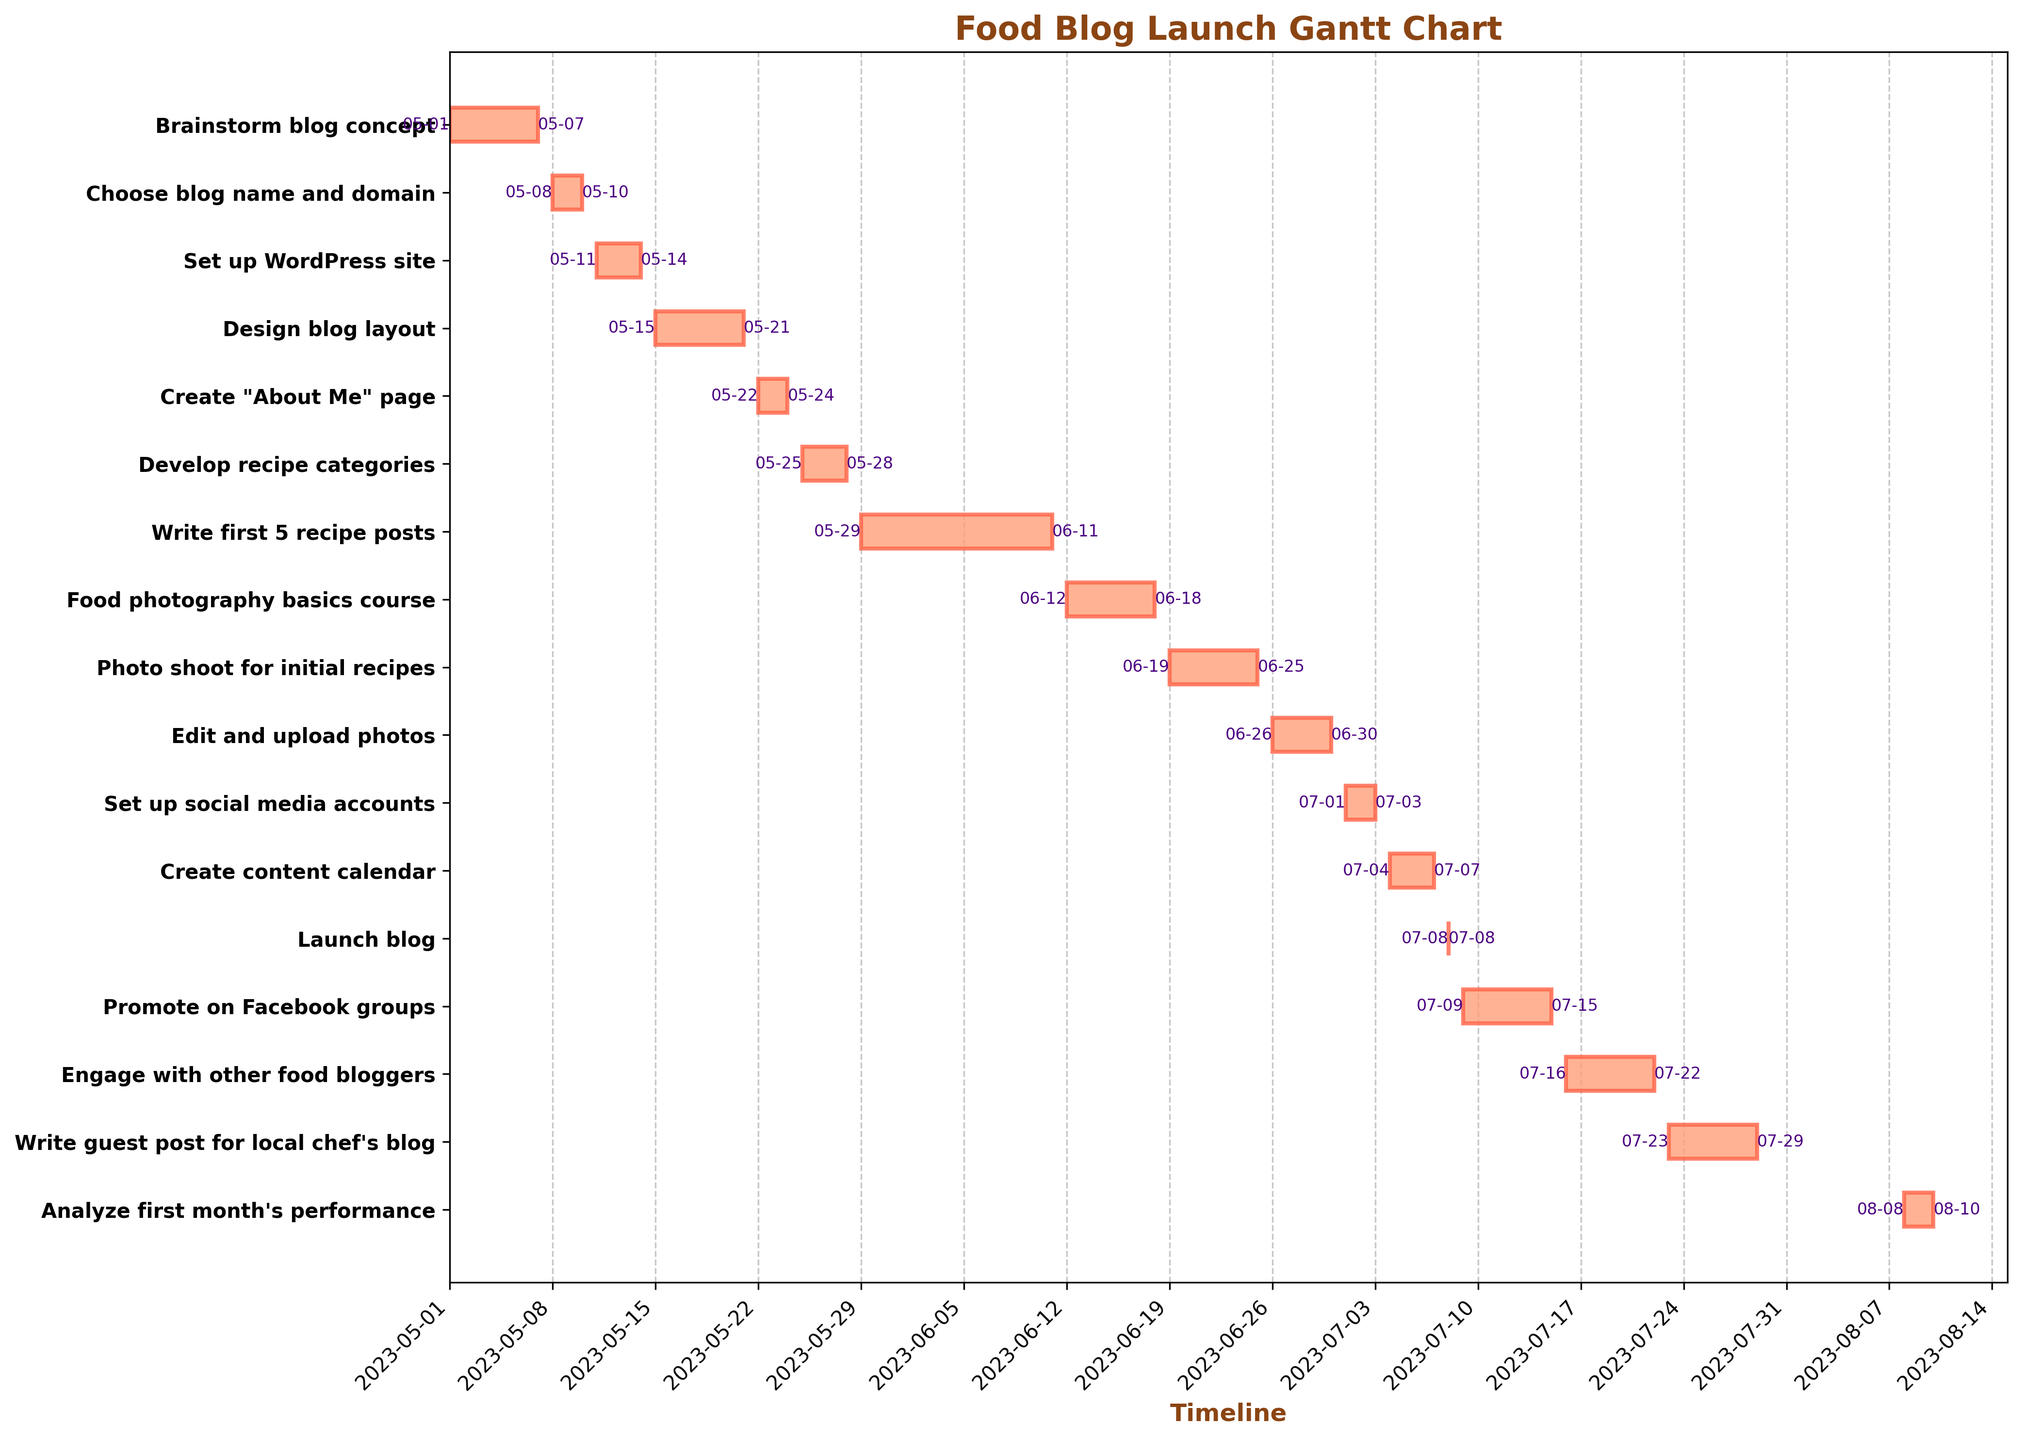What is the title of the Gantt chart? The title is located at the top of the chart and is presented in bold text. Reading the title tells us the main subject or focus of the chart.
Answer: Food Blog Launch Gantt Chart How long did the task 'Brainstorm blog concept' take? To determine the duration, look at the start and end dates (May 1, 2023, to May 7, 2023) and calculate the difference in days.
Answer: 7 days Which task overlaps with setting up the WordPress site? 'Setting up the WordPress site' runs from May 11, 2023, to May 14, 2023. Check for other tasks occurring within or across these dates. 'Choose blog name and domain' ends on May 10 and 'Design blog layout' starts on May 15, so there is no overlap.
Answer: None Which task took the longest time to complete? Examine the lengths of all horizontal bars representing each task. The longest bar corresponds to the task 'Write first 5 recipe posts' with a duration from May 29, 2023, to June 11, 2023.
Answer: Write first 5 recipe posts How many tasks are there in total? Each horizontal bar represents one task. Counting all the bars gives the total number of tasks. There are 17 bars on the chart.
Answer: 17 tasks In which week is the blog officially launched? The launch date, July 8, 2023, falls within a specific week. Identify this week on the timeline axis.
Answer: Week of July 3, 2023 What's the difference in days between the start of the 'Food photography basics course' and the 'Launch blog'? The 'Food photography basics course' starts on June 12, 2023, and 'Launch blog' on July 8, 2023. Calculate the difference in days between these two dates.
Answer: 26 days How many stages/tasks are involved from brainstorming the blog concept to creating the 'About Me' page? Identify and count the bars from 'Brainstorm blog concept' to 'Create "About Me" page' inclusive. These are: Brainstorm blog concept, Choose blog name and domain, Set up WordPress site, Design blog layout, Create "About Me" page.
Answer: 5 tasks Which task immediately follows 'Create content calendar'? 'Create content calendar' ends on July 7, 2023. Identify the next task starting on or after this date. According to the timeline, the 'Launch blog' task follows it on July 8, 2023.
Answer: Launch blog How many days were spent promoting the blog after the launch? Identify the tasks related to promotion after the launch date (July 8, 2023). These tasks are 'Promote on Facebook groups' from July 9 to July 15 and 'Engage with other food bloggers' from July 16 to July 22. Adding their durations: 7 days and 7 days.
Answer: 14 days 